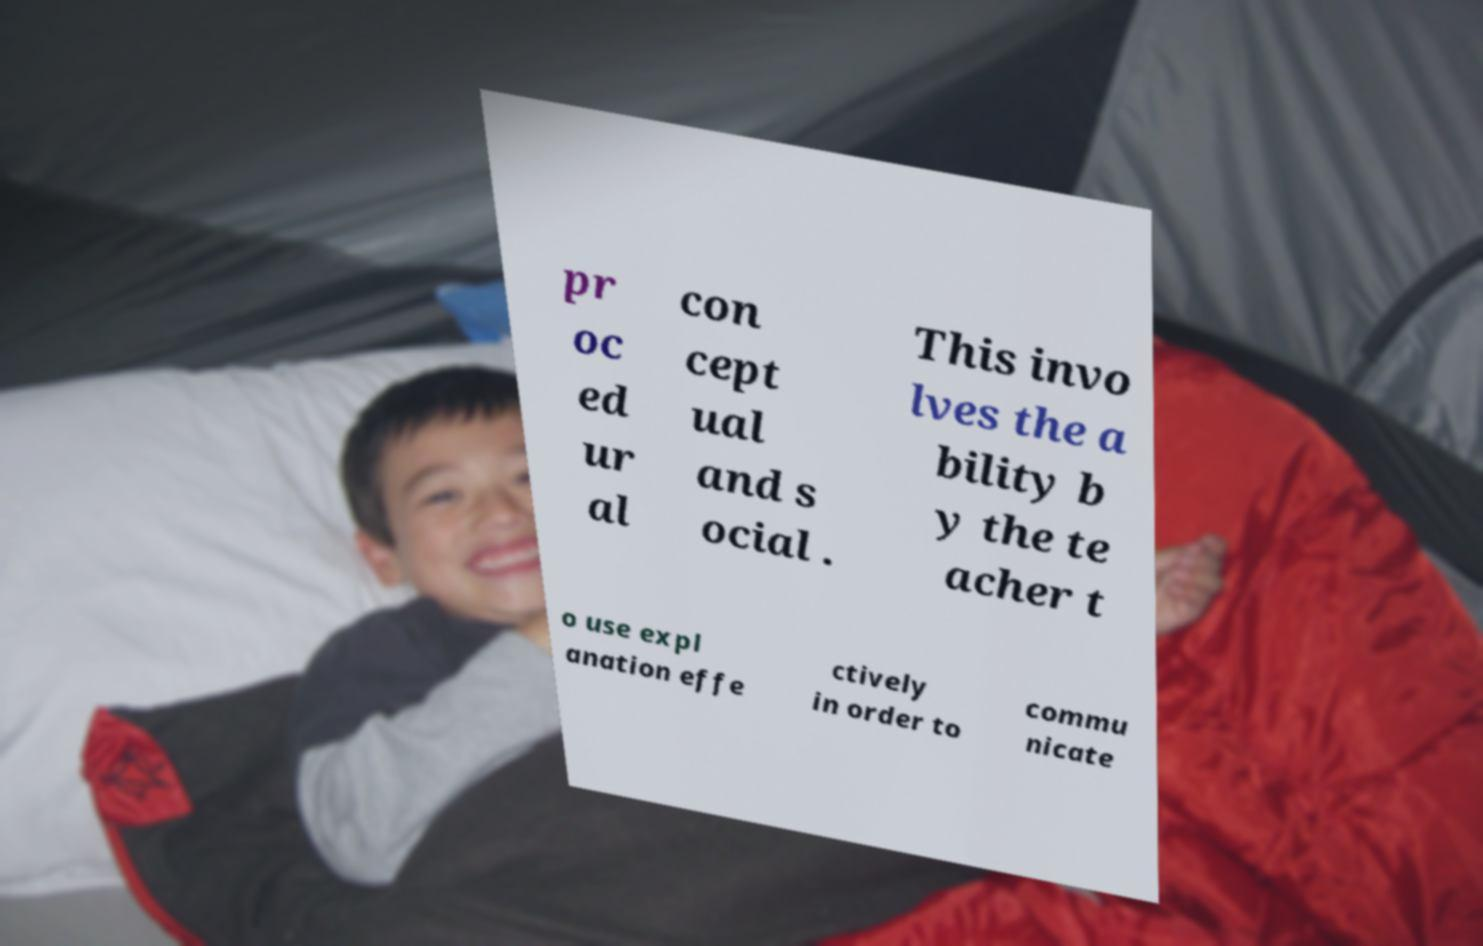Could you assist in decoding the text presented in this image and type it out clearly? pr oc ed ur al con cept ual and s ocial . This invo lves the a bility b y the te acher t o use expl anation effe ctively in order to commu nicate 